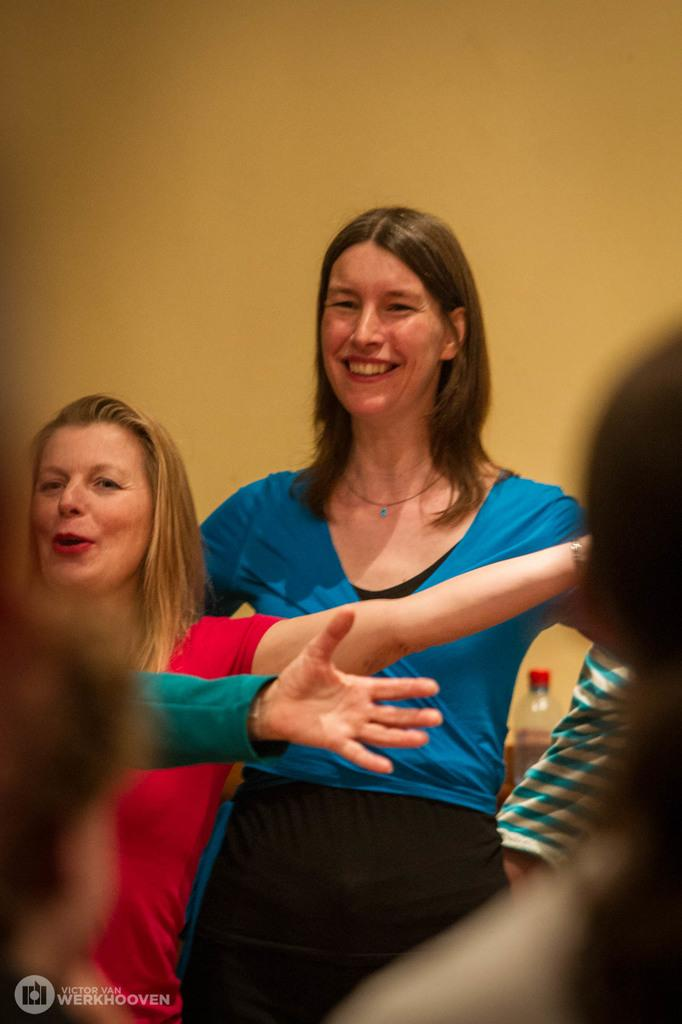Who is the main subject in the image? There is a lady in the center of the image. Can you describe the other people in the image? There are other people in the image, but their specific positions or actions are not mentioned in the facts. What object can be seen in the background of the image? There is a water bottle in the background area of the image. What type of cow can be seen in the image? There is no cow present in the image. Is there a cellar visible in the image? The facts provided do not mention a cellar, so it cannot be determined if one is present in the image. 